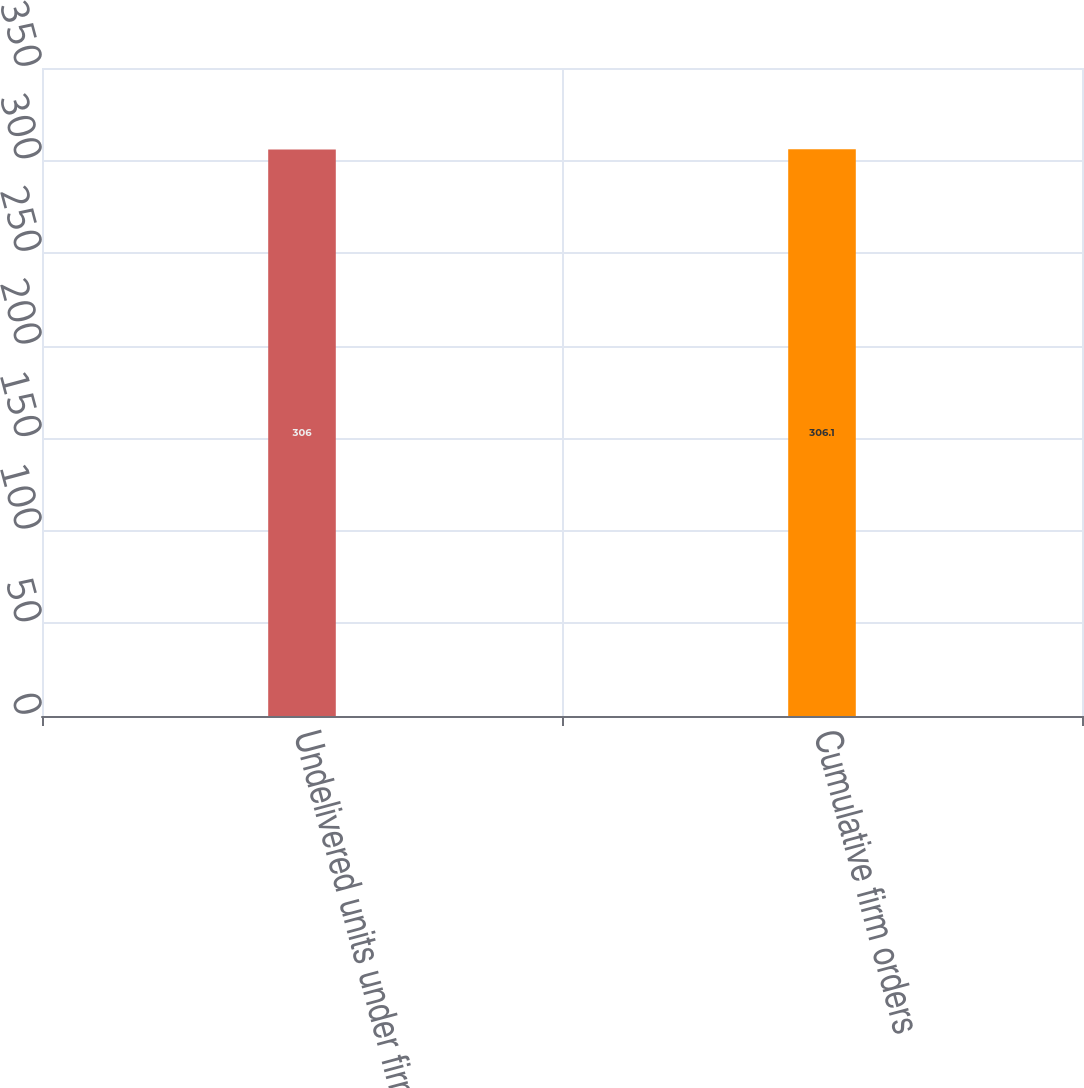Convert chart. <chart><loc_0><loc_0><loc_500><loc_500><bar_chart><fcel>Undelivered units under firm<fcel>Cumulative firm orders<nl><fcel>306<fcel>306.1<nl></chart> 